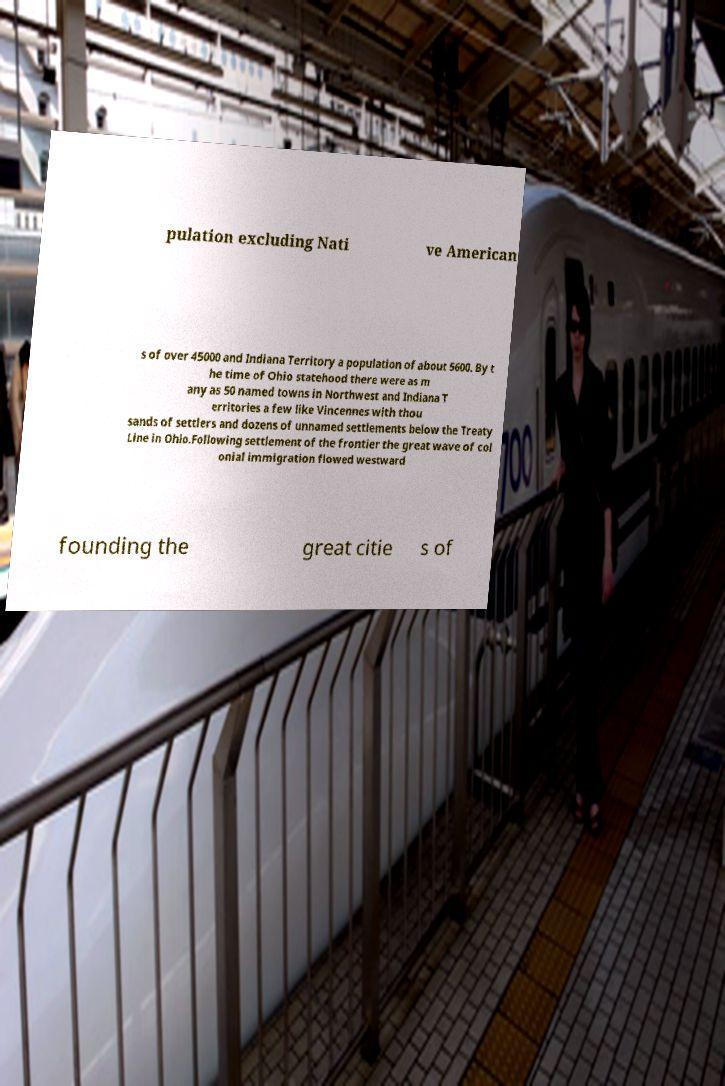For documentation purposes, I need the text within this image transcribed. Could you provide that? pulation excluding Nati ve American s of over 45000 and Indiana Territory a population of about 5600. By t he time of Ohio statehood there were as m any as 50 named towns in Northwest and Indiana T erritories a few like Vincennes with thou sands of settlers and dozens of unnamed settlements below the Treaty Line in Ohio.Following settlement of the frontier the great wave of col onial immigration flowed westward founding the great citie s of 